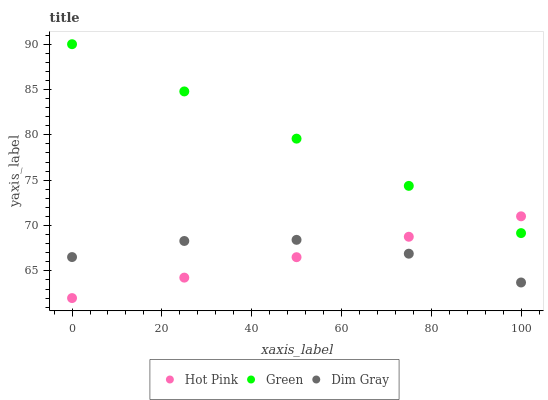Does Hot Pink have the minimum area under the curve?
Answer yes or no. Yes. Does Green have the maximum area under the curve?
Answer yes or no. Yes. Does Green have the minimum area under the curve?
Answer yes or no. No. Does Hot Pink have the maximum area under the curve?
Answer yes or no. No. Is Hot Pink the smoothest?
Answer yes or no. Yes. Is Dim Gray the roughest?
Answer yes or no. Yes. Is Green the smoothest?
Answer yes or no. No. Is Green the roughest?
Answer yes or no. No. Does Hot Pink have the lowest value?
Answer yes or no. Yes. Does Green have the lowest value?
Answer yes or no. No. Does Green have the highest value?
Answer yes or no. Yes. Does Hot Pink have the highest value?
Answer yes or no. No. Is Dim Gray less than Green?
Answer yes or no. Yes. Is Green greater than Dim Gray?
Answer yes or no. Yes. Does Hot Pink intersect Green?
Answer yes or no. Yes. Is Hot Pink less than Green?
Answer yes or no. No. Is Hot Pink greater than Green?
Answer yes or no. No. Does Dim Gray intersect Green?
Answer yes or no. No. 